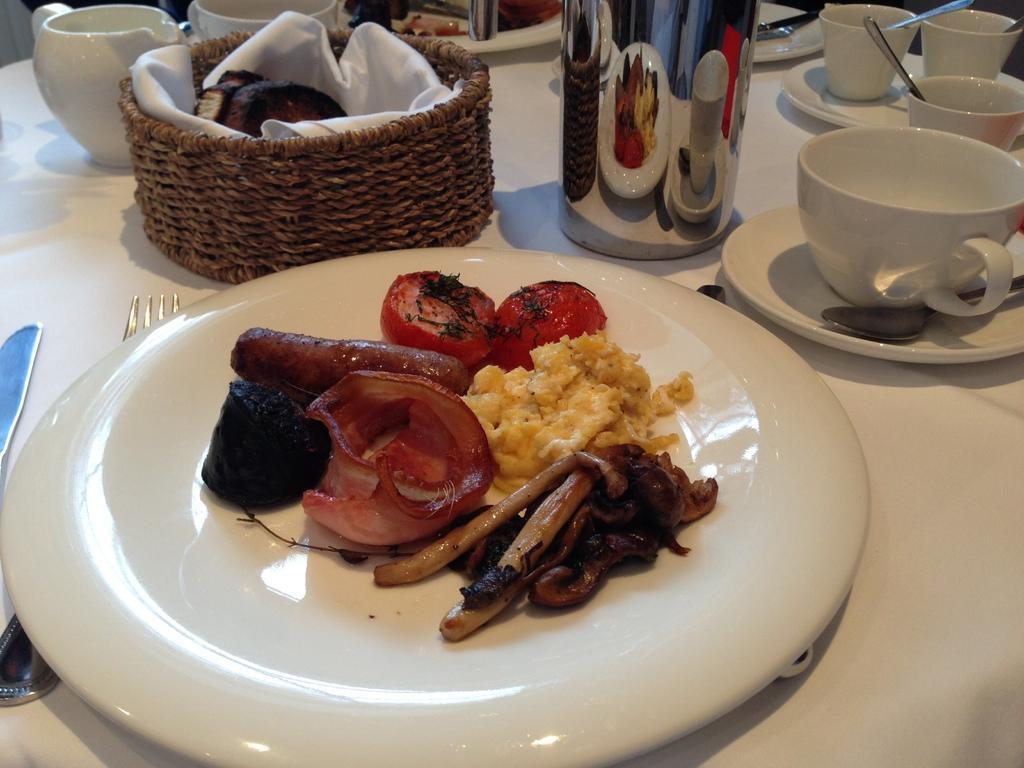Can you describe this image briefly? In the image in the center we can see one table. On the table,we can see one cloth,fork,knife,mug,basket,cups,plates,saucers,spoons,some food items and few other objects. 